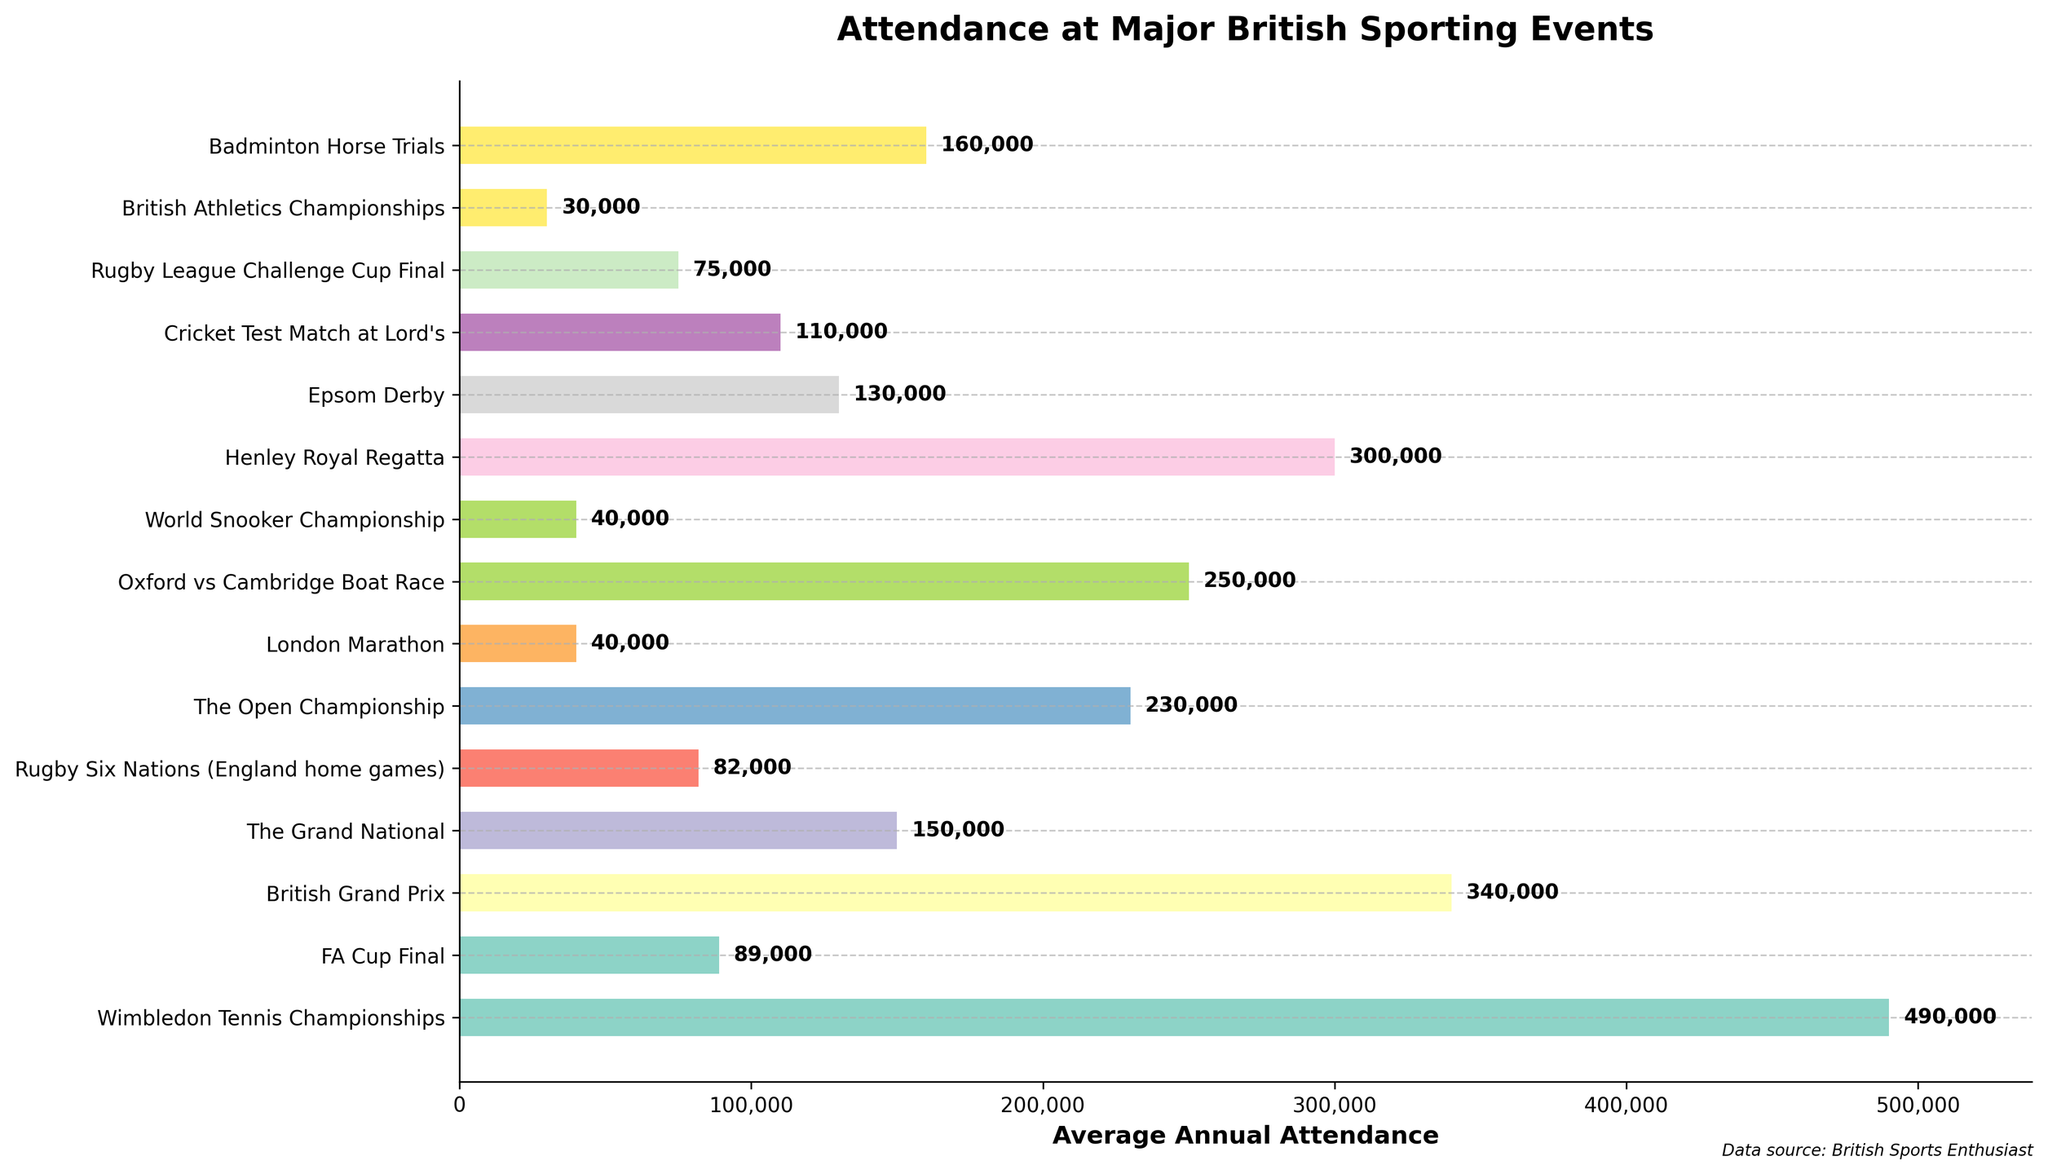What's the event with the highest average annual attendance? Observing the bar chart, the event with the highest bar length represents the highest average annual attendance. The longest bar belongs to Wimbledon Tennis Championships with an attendance of 490,000.
Answer: Wimbledon Tennis Championships Which sporting event has the lowest average annual attendance? By observing the smallest bar in the chart, we determine that the event with the lowest attendance is the British Athletics Championships with 30,000.
Answer: British Athletics Championships What is the total average annual attendance for Wimbledon Tennis Championships and the British Grand Prix? Summing the attendance figures for Wimbledon (490,000) and the British Grand Prix (340,000) gives us the total attendance. 490,000 + 340,000 = 830,000.
Answer: 830,000 Is the FA Cup Final's attendance greater than that of the Grand National? Referring to the lengths of the respective bars, FA Cup Final has an attendance of 89,000 compared to the Grand National's 150,000. 89,000 < 150,000. Thus, the FA Cup Final's attendance is not greater than the Grand National's.
Answer: No Which event has a higher average annual attendance: Epsom Derby or Cricket Test Match at Lord's? Comparing the bars for Epsom Derby (130,000) and Cricket Test Match at Lord's (110,000), Epsom Derby has a higher attendance.
Answer: Epsom Derby What are the combined average annual attendances for the Rugby Six Nations (England home games) and the Rugby League Challenge Cup Final? Adding their attendance figures, Rugby Six Nations (82,000) + Rugby League Challenge Cup Final (75,000) accounts for a total of 82,000 + 75,000 = 157,000.
Answer: 157,000 Which event has the second highest average attendance? By observing the bar chart, after Wimbledon Tennis Championships, the second longest bar is for the Henley Royal Regatta with attendance figures of 300,000.
Answer: Henley Royal Regatta Is the average annual attendance for The Open Championship more or less than twice that of the London Marathon? The attendance for The Open Championship is 230,000. Twice the attendance for the London Marathon is 2 * 40,000 = 80,000. Since 230,000 > 80,000, The Open Championship's attendance is more than twice that of the London Marathon.
Answer: More Comparing World Snooker Championship and the London Marathon, which has higher average attendance? Observing the bar lengths, World Snooker Championship and London Marathon both have the same attendance figure of 40,000 as shown by the equal bar lengths.
Answer: Neither, equal Are the average annual attendances for Wimbledon Tennis Championships and the Henley Royal Regatta more than the combined attendance for the Grand National and The Open Championship? Summing them respectively: Wimbledon (490,000) + Henley Royal Regatta (300,000) = 790,000. Grand National (150,000) + The Open Championship (230,000) = 380,000. Since 790,000 > 380,000, Wimbledon and Henley exceed the combined attendance of the Grand National and The Open Championship.
Answer: Yes 